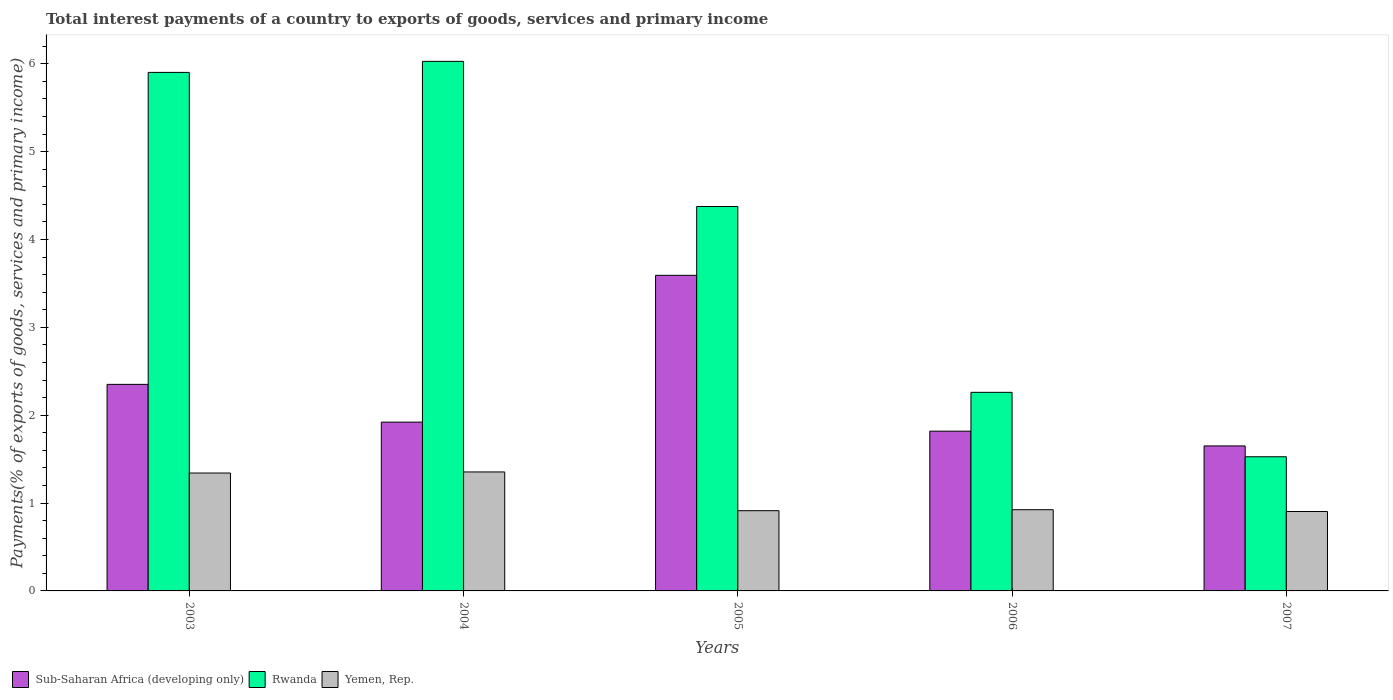How many different coloured bars are there?
Your response must be concise. 3. Are the number of bars on each tick of the X-axis equal?
Your answer should be compact. Yes. What is the label of the 2nd group of bars from the left?
Provide a short and direct response. 2004. What is the total interest payments in Yemen, Rep. in 2007?
Provide a short and direct response. 0.9. Across all years, what is the maximum total interest payments in Rwanda?
Your response must be concise. 6.03. Across all years, what is the minimum total interest payments in Rwanda?
Your answer should be very brief. 1.53. In which year was the total interest payments in Sub-Saharan Africa (developing only) maximum?
Ensure brevity in your answer.  2005. In which year was the total interest payments in Rwanda minimum?
Your response must be concise. 2007. What is the total total interest payments in Rwanda in the graph?
Offer a very short reply. 20.09. What is the difference between the total interest payments in Rwanda in 2004 and that in 2007?
Provide a succinct answer. 4.5. What is the difference between the total interest payments in Sub-Saharan Africa (developing only) in 2006 and the total interest payments in Rwanda in 2004?
Your answer should be compact. -4.21. What is the average total interest payments in Rwanda per year?
Give a very brief answer. 4.02. In the year 2005, what is the difference between the total interest payments in Yemen, Rep. and total interest payments in Sub-Saharan Africa (developing only)?
Your response must be concise. -2.68. What is the ratio of the total interest payments in Rwanda in 2004 to that in 2006?
Offer a very short reply. 2.67. Is the total interest payments in Sub-Saharan Africa (developing only) in 2005 less than that in 2006?
Your answer should be compact. No. Is the difference between the total interest payments in Yemen, Rep. in 2003 and 2005 greater than the difference between the total interest payments in Sub-Saharan Africa (developing only) in 2003 and 2005?
Your response must be concise. Yes. What is the difference between the highest and the second highest total interest payments in Yemen, Rep.?
Your answer should be compact. 0.01. What is the difference between the highest and the lowest total interest payments in Sub-Saharan Africa (developing only)?
Give a very brief answer. 1.94. Is the sum of the total interest payments in Yemen, Rep. in 2004 and 2005 greater than the maximum total interest payments in Sub-Saharan Africa (developing only) across all years?
Keep it short and to the point. No. What does the 1st bar from the left in 2005 represents?
Ensure brevity in your answer.  Sub-Saharan Africa (developing only). What does the 1st bar from the right in 2004 represents?
Ensure brevity in your answer.  Yemen, Rep. Is it the case that in every year, the sum of the total interest payments in Rwanda and total interest payments in Yemen, Rep. is greater than the total interest payments in Sub-Saharan Africa (developing only)?
Provide a succinct answer. Yes. How many years are there in the graph?
Your answer should be very brief. 5. Where does the legend appear in the graph?
Keep it short and to the point. Bottom left. How many legend labels are there?
Keep it short and to the point. 3. What is the title of the graph?
Make the answer very short. Total interest payments of a country to exports of goods, services and primary income. What is the label or title of the Y-axis?
Your answer should be very brief. Payments(% of exports of goods, services and primary income). What is the Payments(% of exports of goods, services and primary income) in Sub-Saharan Africa (developing only) in 2003?
Offer a terse response. 2.35. What is the Payments(% of exports of goods, services and primary income) in Rwanda in 2003?
Ensure brevity in your answer.  5.9. What is the Payments(% of exports of goods, services and primary income) in Yemen, Rep. in 2003?
Make the answer very short. 1.34. What is the Payments(% of exports of goods, services and primary income) of Sub-Saharan Africa (developing only) in 2004?
Offer a terse response. 1.92. What is the Payments(% of exports of goods, services and primary income) of Rwanda in 2004?
Provide a short and direct response. 6.03. What is the Payments(% of exports of goods, services and primary income) of Yemen, Rep. in 2004?
Provide a succinct answer. 1.35. What is the Payments(% of exports of goods, services and primary income) of Sub-Saharan Africa (developing only) in 2005?
Ensure brevity in your answer.  3.59. What is the Payments(% of exports of goods, services and primary income) in Rwanda in 2005?
Your answer should be very brief. 4.38. What is the Payments(% of exports of goods, services and primary income) of Yemen, Rep. in 2005?
Offer a terse response. 0.91. What is the Payments(% of exports of goods, services and primary income) in Sub-Saharan Africa (developing only) in 2006?
Provide a succinct answer. 1.82. What is the Payments(% of exports of goods, services and primary income) in Rwanda in 2006?
Ensure brevity in your answer.  2.26. What is the Payments(% of exports of goods, services and primary income) of Yemen, Rep. in 2006?
Your response must be concise. 0.92. What is the Payments(% of exports of goods, services and primary income) of Sub-Saharan Africa (developing only) in 2007?
Your answer should be very brief. 1.65. What is the Payments(% of exports of goods, services and primary income) in Rwanda in 2007?
Make the answer very short. 1.53. What is the Payments(% of exports of goods, services and primary income) in Yemen, Rep. in 2007?
Make the answer very short. 0.9. Across all years, what is the maximum Payments(% of exports of goods, services and primary income) of Sub-Saharan Africa (developing only)?
Keep it short and to the point. 3.59. Across all years, what is the maximum Payments(% of exports of goods, services and primary income) in Rwanda?
Offer a terse response. 6.03. Across all years, what is the maximum Payments(% of exports of goods, services and primary income) in Yemen, Rep.?
Make the answer very short. 1.35. Across all years, what is the minimum Payments(% of exports of goods, services and primary income) of Sub-Saharan Africa (developing only)?
Your response must be concise. 1.65. Across all years, what is the minimum Payments(% of exports of goods, services and primary income) in Rwanda?
Your response must be concise. 1.53. Across all years, what is the minimum Payments(% of exports of goods, services and primary income) of Yemen, Rep.?
Offer a very short reply. 0.9. What is the total Payments(% of exports of goods, services and primary income) of Sub-Saharan Africa (developing only) in the graph?
Make the answer very short. 11.33. What is the total Payments(% of exports of goods, services and primary income) of Rwanda in the graph?
Keep it short and to the point. 20.09. What is the total Payments(% of exports of goods, services and primary income) in Yemen, Rep. in the graph?
Provide a succinct answer. 5.44. What is the difference between the Payments(% of exports of goods, services and primary income) of Sub-Saharan Africa (developing only) in 2003 and that in 2004?
Provide a succinct answer. 0.43. What is the difference between the Payments(% of exports of goods, services and primary income) in Rwanda in 2003 and that in 2004?
Make the answer very short. -0.13. What is the difference between the Payments(% of exports of goods, services and primary income) in Yemen, Rep. in 2003 and that in 2004?
Your answer should be compact. -0.01. What is the difference between the Payments(% of exports of goods, services and primary income) in Sub-Saharan Africa (developing only) in 2003 and that in 2005?
Provide a short and direct response. -1.24. What is the difference between the Payments(% of exports of goods, services and primary income) of Rwanda in 2003 and that in 2005?
Make the answer very short. 1.53. What is the difference between the Payments(% of exports of goods, services and primary income) of Yemen, Rep. in 2003 and that in 2005?
Your answer should be very brief. 0.43. What is the difference between the Payments(% of exports of goods, services and primary income) in Sub-Saharan Africa (developing only) in 2003 and that in 2006?
Your answer should be compact. 0.53. What is the difference between the Payments(% of exports of goods, services and primary income) of Rwanda in 2003 and that in 2006?
Offer a very short reply. 3.64. What is the difference between the Payments(% of exports of goods, services and primary income) of Yemen, Rep. in 2003 and that in 2006?
Your response must be concise. 0.42. What is the difference between the Payments(% of exports of goods, services and primary income) of Sub-Saharan Africa (developing only) in 2003 and that in 2007?
Provide a short and direct response. 0.7. What is the difference between the Payments(% of exports of goods, services and primary income) of Rwanda in 2003 and that in 2007?
Make the answer very short. 4.37. What is the difference between the Payments(% of exports of goods, services and primary income) in Yemen, Rep. in 2003 and that in 2007?
Give a very brief answer. 0.44. What is the difference between the Payments(% of exports of goods, services and primary income) of Sub-Saharan Africa (developing only) in 2004 and that in 2005?
Ensure brevity in your answer.  -1.67. What is the difference between the Payments(% of exports of goods, services and primary income) in Rwanda in 2004 and that in 2005?
Provide a succinct answer. 1.65. What is the difference between the Payments(% of exports of goods, services and primary income) in Yemen, Rep. in 2004 and that in 2005?
Give a very brief answer. 0.44. What is the difference between the Payments(% of exports of goods, services and primary income) of Sub-Saharan Africa (developing only) in 2004 and that in 2006?
Provide a short and direct response. 0.1. What is the difference between the Payments(% of exports of goods, services and primary income) of Rwanda in 2004 and that in 2006?
Your response must be concise. 3.77. What is the difference between the Payments(% of exports of goods, services and primary income) of Yemen, Rep. in 2004 and that in 2006?
Your answer should be compact. 0.43. What is the difference between the Payments(% of exports of goods, services and primary income) of Sub-Saharan Africa (developing only) in 2004 and that in 2007?
Your response must be concise. 0.27. What is the difference between the Payments(% of exports of goods, services and primary income) of Rwanda in 2004 and that in 2007?
Your answer should be compact. 4.5. What is the difference between the Payments(% of exports of goods, services and primary income) of Yemen, Rep. in 2004 and that in 2007?
Your answer should be very brief. 0.45. What is the difference between the Payments(% of exports of goods, services and primary income) in Sub-Saharan Africa (developing only) in 2005 and that in 2006?
Provide a succinct answer. 1.77. What is the difference between the Payments(% of exports of goods, services and primary income) in Rwanda in 2005 and that in 2006?
Give a very brief answer. 2.12. What is the difference between the Payments(% of exports of goods, services and primary income) in Yemen, Rep. in 2005 and that in 2006?
Make the answer very short. -0.01. What is the difference between the Payments(% of exports of goods, services and primary income) in Sub-Saharan Africa (developing only) in 2005 and that in 2007?
Offer a very short reply. 1.94. What is the difference between the Payments(% of exports of goods, services and primary income) of Rwanda in 2005 and that in 2007?
Provide a succinct answer. 2.85. What is the difference between the Payments(% of exports of goods, services and primary income) in Yemen, Rep. in 2005 and that in 2007?
Offer a very short reply. 0.01. What is the difference between the Payments(% of exports of goods, services and primary income) in Sub-Saharan Africa (developing only) in 2006 and that in 2007?
Your answer should be compact. 0.17. What is the difference between the Payments(% of exports of goods, services and primary income) in Rwanda in 2006 and that in 2007?
Your response must be concise. 0.73. What is the difference between the Payments(% of exports of goods, services and primary income) of Yemen, Rep. in 2006 and that in 2007?
Keep it short and to the point. 0.02. What is the difference between the Payments(% of exports of goods, services and primary income) of Sub-Saharan Africa (developing only) in 2003 and the Payments(% of exports of goods, services and primary income) of Rwanda in 2004?
Your response must be concise. -3.68. What is the difference between the Payments(% of exports of goods, services and primary income) of Sub-Saharan Africa (developing only) in 2003 and the Payments(% of exports of goods, services and primary income) of Yemen, Rep. in 2004?
Provide a succinct answer. 1. What is the difference between the Payments(% of exports of goods, services and primary income) in Rwanda in 2003 and the Payments(% of exports of goods, services and primary income) in Yemen, Rep. in 2004?
Provide a succinct answer. 4.55. What is the difference between the Payments(% of exports of goods, services and primary income) of Sub-Saharan Africa (developing only) in 2003 and the Payments(% of exports of goods, services and primary income) of Rwanda in 2005?
Ensure brevity in your answer.  -2.02. What is the difference between the Payments(% of exports of goods, services and primary income) of Sub-Saharan Africa (developing only) in 2003 and the Payments(% of exports of goods, services and primary income) of Yemen, Rep. in 2005?
Provide a succinct answer. 1.44. What is the difference between the Payments(% of exports of goods, services and primary income) of Rwanda in 2003 and the Payments(% of exports of goods, services and primary income) of Yemen, Rep. in 2005?
Ensure brevity in your answer.  4.99. What is the difference between the Payments(% of exports of goods, services and primary income) in Sub-Saharan Africa (developing only) in 2003 and the Payments(% of exports of goods, services and primary income) in Rwanda in 2006?
Your answer should be compact. 0.09. What is the difference between the Payments(% of exports of goods, services and primary income) of Sub-Saharan Africa (developing only) in 2003 and the Payments(% of exports of goods, services and primary income) of Yemen, Rep. in 2006?
Offer a very short reply. 1.43. What is the difference between the Payments(% of exports of goods, services and primary income) in Rwanda in 2003 and the Payments(% of exports of goods, services and primary income) in Yemen, Rep. in 2006?
Give a very brief answer. 4.98. What is the difference between the Payments(% of exports of goods, services and primary income) in Sub-Saharan Africa (developing only) in 2003 and the Payments(% of exports of goods, services and primary income) in Rwanda in 2007?
Provide a short and direct response. 0.82. What is the difference between the Payments(% of exports of goods, services and primary income) in Sub-Saharan Africa (developing only) in 2003 and the Payments(% of exports of goods, services and primary income) in Yemen, Rep. in 2007?
Offer a terse response. 1.45. What is the difference between the Payments(% of exports of goods, services and primary income) in Rwanda in 2003 and the Payments(% of exports of goods, services and primary income) in Yemen, Rep. in 2007?
Provide a succinct answer. 5. What is the difference between the Payments(% of exports of goods, services and primary income) in Sub-Saharan Africa (developing only) in 2004 and the Payments(% of exports of goods, services and primary income) in Rwanda in 2005?
Provide a short and direct response. -2.45. What is the difference between the Payments(% of exports of goods, services and primary income) of Sub-Saharan Africa (developing only) in 2004 and the Payments(% of exports of goods, services and primary income) of Yemen, Rep. in 2005?
Offer a terse response. 1.01. What is the difference between the Payments(% of exports of goods, services and primary income) of Rwanda in 2004 and the Payments(% of exports of goods, services and primary income) of Yemen, Rep. in 2005?
Ensure brevity in your answer.  5.11. What is the difference between the Payments(% of exports of goods, services and primary income) of Sub-Saharan Africa (developing only) in 2004 and the Payments(% of exports of goods, services and primary income) of Rwanda in 2006?
Your answer should be compact. -0.34. What is the difference between the Payments(% of exports of goods, services and primary income) of Sub-Saharan Africa (developing only) in 2004 and the Payments(% of exports of goods, services and primary income) of Yemen, Rep. in 2006?
Your answer should be compact. 1. What is the difference between the Payments(% of exports of goods, services and primary income) in Rwanda in 2004 and the Payments(% of exports of goods, services and primary income) in Yemen, Rep. in 2006?
Your answer should be compact. 5.1. What is the difference between the Payments(% of exports of goods, services and primary income) of Sub-Saharan Africa (developing only) in 2004 and the Payments(% of exports of goods, services and primary income) of Rwanda in 2007?
Give a very brief answer. 0.39. What is the difference between the Payments(% of exports of goods, services and primary income) of Sub-Saharan Africa (developing only) in 2004 and the Payments(% of exports of goods, services and primary income) of Yemen, Rep. in 2007?
Offer a terse response. 1.02. What is the difference between the Payments(% of exports of goods, services and primary income) of Rwanda in 2004 and the Payments(% of exports of goods, services and primary income) of Yemen, Rep. in 2007?
Give a very brief answer. 5.12. What is the difference between the Payments(% of exports of goods, services and primary income) of Sub-Saharan Africa (developing only) in 2005 and the Payments(% of exports of goods, services and primary income) of Rwanda in 2006?
Offer a very short reply. 1.33. What is the difference between the Payments(% of exports of goods, services and primary income) in Sub-Saharan Africa (developing only) in 2005 and the Payments(% of exports of goods, services and primary income) in Yemen, Rep. in 2006?
Offer a terse response. 2.67. What is the difference between the Payments(% of exports of goods, services and primary income) of Rwanda in 2005 and the Payments(% of exports of goods, services and primary income) of Yemen, Rep. in 2006?
Ensure brevity in your answer.  3.45. What is the difference between the Payments(% of exports of goods, services and primary income) of Sub-Saharan Africa (developing only) in 2005 and the Payments(% of exports of goods, services and primary income) of Rwanda in 2007?
Provide a succinct answer. 2.06. What is the difference between the Payments(% of exports of goods, services and primary income) of Sub-Saharan Africa (developing only) in 2005 and the Payments(% of exports of goods, services and primary income) of Yemen, Rep. in 2007?
Give a very brief answer. 2.69. What is the difference between the Payments(% of exports of goods, services and primary income) of Rwanda in 2005 and the Payments(% of exports of goods, services and primary income) of Yemen, Rep. in 2007?
Make the answer very short. 3.47. What is the difference between the Payments(% of exports of goods, services and primary income) of Sub-Saharan Africa (developing only) in 2006 and the Payments(% of exports of goods, services and primary income) of Rwanda in 2007?
Offer a very short reply. 0.29. What is the difference between the Payments(% of exports of goods, services and primary income) in Sub-Saharan Africa (developing only) in 2006 and the Payments(% of exports of goods, services and primary income) in Yemen, Rep. in 2007?
Provide a succinct answer. 0.91. What is the difference between the Payments(% of exports of goods, services and primary income) of Rwanda in 2006 and the Payments(% of exports of goods, services and primary income) of Yemen, Rep. in 2007?
Make the answer very short. 1.36. What is the average Payments(% of exports of goods, services and primary income) of Sub-Saharan Africa (developing only) per year?
Ensure brevity in your answer.  2.27. What is the average Payments(% of exports of goods, services and primary income) of Rwanda per year?
Provide a short and direct response. 4.02. What is the average Payments(% of exports of goods, services and primary income) of Yemen, Rep. per year?
Make the answer very short. 1.09. In the year 2003, what is the difference between the Payments(% of exports of goods, services and primary income) of Sub-Saharan Africa (developing only) and Payments(% of exports of goods, services and primary income) of Rwanda?
Keep it short and to the point. -3.55. In the year 2003, what is the difference between the Payments(% of exports of goods, services and primary income) of Sub-Saharan Africa (developing only) and Payments(% of exports of goods, services and primary income) of Yemen, Rep.?
Your answer should be compact. 1.01. In the year 2003, what is the difference between the Payments(% of exports of goods, services and primary income) of Rwanda and Payments(% of exports of goods, services and primary income) of Yemen, Rep.?
Provide a short and direct response. 4.56. In the year 2004, what is the difference between the Payments(% of exports of goods, services and primary income) of Sub-Saharan Africa (developing only) and Payments(% of exports of goods, services and primary income) of Rwanda?
Ensure brevity in your answer.  -4.11. In the year 2004, what is the difference between the Payments(% of exports of goods, services and primary income) in Sub-Saharan Africa (developing only) and Payments(% of exports of goods, services and primary income) in Yemen, Rep.?
Provide a succinct answer. 0.57. In the year 2004, what is the difference between the Payments(% of exports of goods, services and primary income) in Rwanda and Payments(% of exports of goods, services and primary income) in Yemen, Rep.?
Offer a terse response. 4.67. In the year 2005, what is the difference between the Payments(% of exports of goods, services and primary income) of Sub-Saharan Africa (developing only) and Payments(% of exports of goods, services and primary income) of Rwanda?
Your answer should be very brief. -0.78. In the year 2005, what is the difference between the Payments(% of exports of goods, services and primary income) of Sub-Saharan Africa (developing only) and Payments(% of exports of goods, services and primary income) of Yemen, Rep.?
Keep it short and to the point. 2.68. In the year 2005, what is the difference between the Payments(% of exports of goods, services and primary income) in Rwanda and Payments(% of exports of goods, services and primary income) in Yemen, Rep.?
Your response must be concise. 3.46. In the year 2006, what is the difference between the Payments(% of exports of goods, services and primary income) of Sub-Saharan Africa (developing only) and Payments(% of exports of goods, services and primary income) of Rwanda?
Provide a succinct answer. -0.44. In the year 2006, what is the difference between the Payments(% of exports of goods, services and primary income) of Sub-Saharan Africa (developing only) and Payments(% of exports of goods, services and primary income) of Yemen, Rep.?
Your response must be concise. 0.89. In the year 2006, what is the difference between the Payments(% of exports of goods, services and primary income) in Rwanda and Payments(% of exports of goods, services and primary income) in Yemen, Rep.?
Provide a short and direct response. 1.34. In the year 2007, what is the difference between the Payments(% of exports of goods, services and primary income) of Sub-Saharan Africa (developing only) and Payments(% of exports of goods, services and primary income) of Rwanda?
Keep it short and to the point. 0.12. In the year 2007, what is the difference between the Payments(% of exports of goods, services and primary income) in Sub-Saharan Africa (developing only) and Payments(% of exports of goods, services and primary income) in Yemen, Rep.?
Provide a succinct answer. 0.75. In the year 2007, what is the difference between the Payments(% of exports of goods, services and primary income) of Rwanda and Payments(% of exports of goods, services and primary income) of Yemen, Rep.?
Give a very brief answer. 0.62. What is the ratio of the Payments(% of exports of goods, services and primary income) in Sub-Saharan Africa (developing only) in 2003 to that in 2004?
Give a very brief answer. 1.22. What is the ratio of the Payments(% of exports of goods, services and primary income) of Rwanda in 2003 to that in 2004?
Offer a very short reply. 0.98. What is the ratio of the Payments(% of exports of goods, services and primary income) in Yemen, Rep. in 2003 to that in 2004?
Your answer should be very brief. 0.99. What is the ratio of the Payments(% of exports of goods, services and primary income) of Sub-Saharan Africa (developing only) in 2003 to that in 2005?
Your response must be concise. 0.65. What is the ratio of the Payments(% of exports of goods, services and primary income) of Rwanda in 2003 to that in 2005?
Your answer should be compact. 1.35. What is the ratio of the Payments(% of exports of goods, services and primary income) of Yemen, Rep. in 2003 to that in 2005?
Your response must be concise. 1.47. What is the ratio of the Payments(% of exports of goods, services and primary income) of Sub-Saharan Africa (developing only) in 2003 to that in 2006?
Give a very brief answer. 1.29. What is the ratio of the Payments(% of exports of goods, services and primary income) in Rwanda in 2003 to that in 2006?
Your response must be concise. 2.61. What is the ratio of the Payments(% of exports of goods, services and primary income) of Yemen, Rep. in 2003 to that in 2006?
Your answer should be very brief. 1.45. What is the ratio of the Payments(% of exports of goods, services and primary income) in Sub-Saharan Africa (developing only) in 2003 to that in 2007?
Ensure brevity in your answer.  1.42. What is the ratio of the Payments(% of exports of goods, services and primary income) of Rwanda in 2003 to that in 2007?
Keep it short and to the point. 3.86. What is the ratio of the Payments(% of exports of goods, services and primary income) of Yemen, Rep. in 2003 to that in 2007?
Your answer should be compact. 1.48. What is the ratio of the Payments(% of exports of goods, services and primary income) of Sub-Saharan Africa (developing only) in 2004 to that in 2005?
Make the answer very short. 0.53. What is the ratio of the Payments(% of exports of goods, services and primary income) in Rwanda in 2004 to that in 2005?
Your response must be concise. 1.38. What is the ratio of the Payments(% of exports of goods, services and primary income) of Yemen, Rep. in 2004 to that in 2005?
Ensure brevity in your answer.  1.48. What is the ratio of the Payments(% of exports of goods, services and primary income) of Sub-Saharan Africa (developing only) in 2004 to that in 2006?
Your response must be concise. 1.06. What is the ratio of the Payments(% of exports of goods, services and primary income) of Rwanda in 2004 to that in 2006?
Your answer should be very brief. 2.67. What is the ratio of the Payments(% of exports of goods, services and primary income) in Yemen, Rep. in 2004 to that in 2006?
Make the answer very short. 1.47. What is the ratio of the Payments(% of exports of goods, services and primary income) in Sub-Saharan Africa (developing only) in 2004 to that in 2007?
Provide a succinct answer. 1.16. What is the ratio of the Payments(% of exports of goods, services and primary income) in Rwanda in 2004 to that in 2007?
Give a very brief answer. 3.95. What is the ratio of the Payments(% of exports of goods, services and primary income) of Yemen, Rep. in 2004 to that in 2007?
Your response must be concise. 1.5. What is the ratio of the Payments(% of exports of goods, services and primary income) of Sub-Saharan Africa (developing only) in 2005 to that in 2006?
Ensure brevity in your answer.  1.98. What is the ratio of the Payments(% of exports of goods, services and primary income) in Rwanda in 2005 to that in 2006?
Your answer should be very brief. 1.94. What is the ratio of the Payments(% of exports of goods, services and primary income) in Yemen, Rep. in 2005 to that in 2006?
Ensure brevity in your answer.  0.99. What is the ratio of the Payments(% of exports of goods, services and primary income) of Sub-Saharan Africa (developing only) in 2005 to that in 2007?
Provide a succinct answer. 2.18. What is the ratio of the Payments(% of exports of goods, services and primary income) of Rwanda in 2005 to that in 2007?
Offer a terse response. 2.87. What is the ratio of the Payments(% of exports of goods, services and primary income) in Yemen, Rep. in 2005 to that in 2007?
Give a very brief answer. 1.01. What is the ratio of the Payments(% of exports of goods, services and primary income) in Sub-Saharan Africa (developing only) in 2006 to that in 2007?
Provide a short and direct response. 1.1. What is the ratio of the Payments(% of exports of goods, services and primary income) of Rwanda in 2006 to that in 2007?
Your answer should be compact. 1.48. What is the ratio of the Payments(% of exports of goods, services and primary income) in Yemen, Rep. in 2006 to that in 2007?
Your answer should be compact. 1.02. What is the difference between the highest and the second highest Payments(% of exports of goods, services and primary income) in Sub-Saharan Africa (developing only)?
Offer a very short reply. 1.24. What is the difference between the highest and the second highest Payments(% of exports of goods, services and primary income) in Rwanda?
Give a very brief answer. 0.13. What is the difference between the highest and the second highest Payments(% of exports of goods, services and primary income) of Yemen, Rep.?
Provide a succinct answer. 0.01. What is the difference between the highest and the lowest Payments(% of exports of goods, services and primary income) of Sub-Saharan Africa (developing only)?
Offer a very short reply. 1.94. What is the difference between the highest and the lowest Payments(% of exports of goods, services and primary income) of Yemen, Rep.?
Keep it short and to the point. 0.45. 